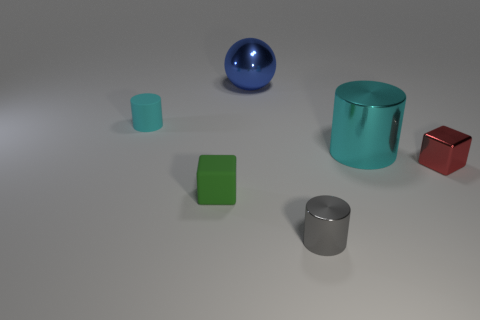Add 1 metallic cylinders. How many objects exist? 7 Subtract all gray cylinders. How many cylinders are left? 2 Subtract all green cubes. How many cubes are left? 1 Subtract 1 blocks. How many blocks are left? 1 Subtract all balls. How many objects are left? 5 Subtract all purple blocks. Subtract all purple cylinders. How many blocks are left? 2 Subtract all gray cylinders. How many green cubes are left? 1 Add 5 blue metallic objects. How many blue metallic objects exist? 6 Subtract 0 yellow cylinders. How many objects are left? 6 Subtract all brown matte cylinders. Subtract all large cyan cylinders. How many objects are left? 5 